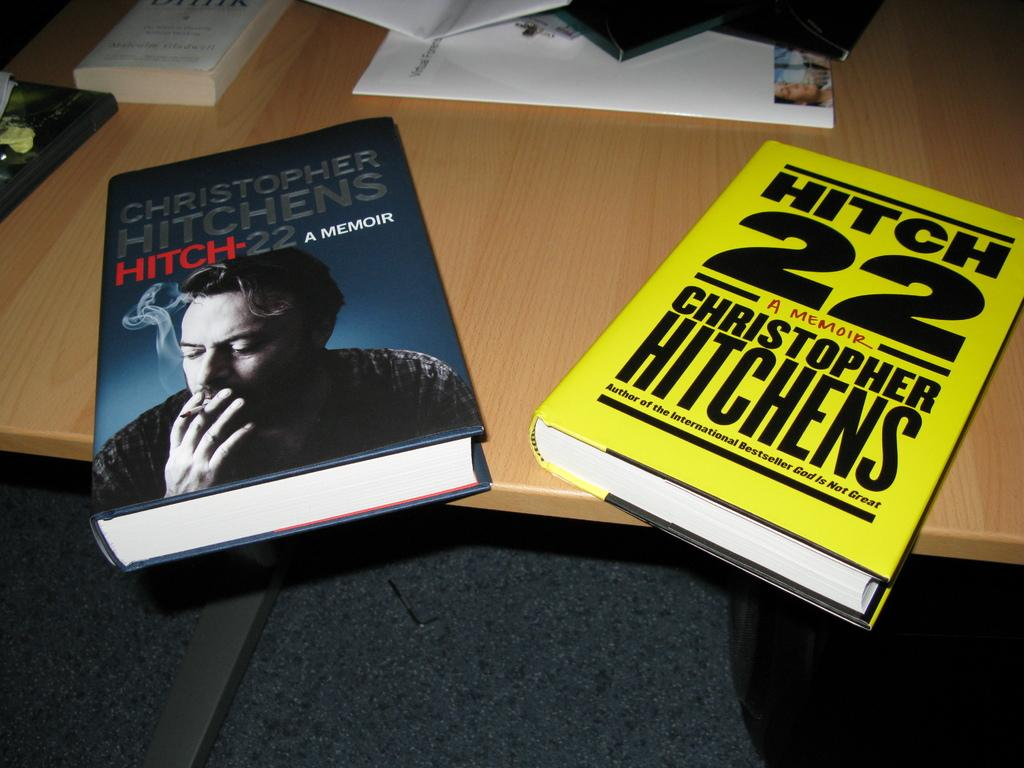<image>
Offer a succinct explanation of the picture presented. Two copies of the Christopher Hitchens book "Hitch-22" have very different covers. 